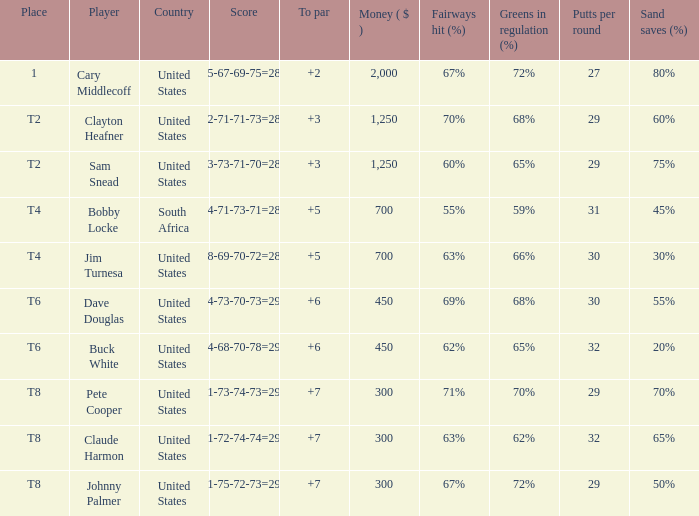What is claude harmon's location? T8. 